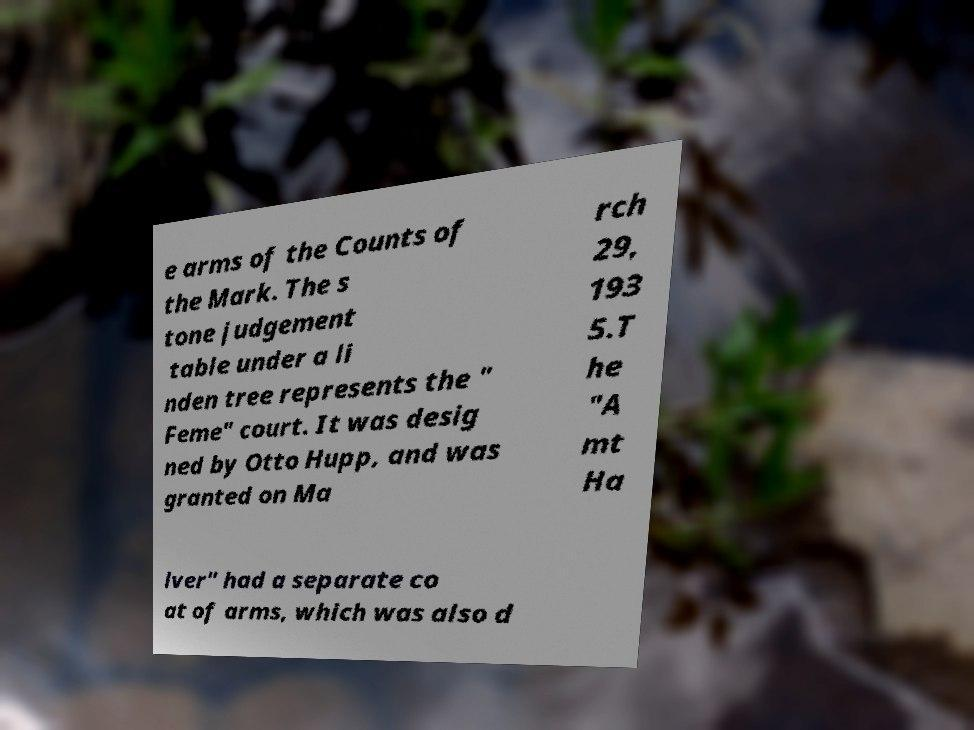Could you assist in decoding the text presented in this image and type it out clearly? e arms of the Counts of the Mark. The s tone judgement table under a li nden tree represents the " Feme" court. It was desig ned by Otto Hupp, and was granted on Ma rch 29, 193 5.T he "A mt Ha lver" had a separate co at of arms, which was also d 